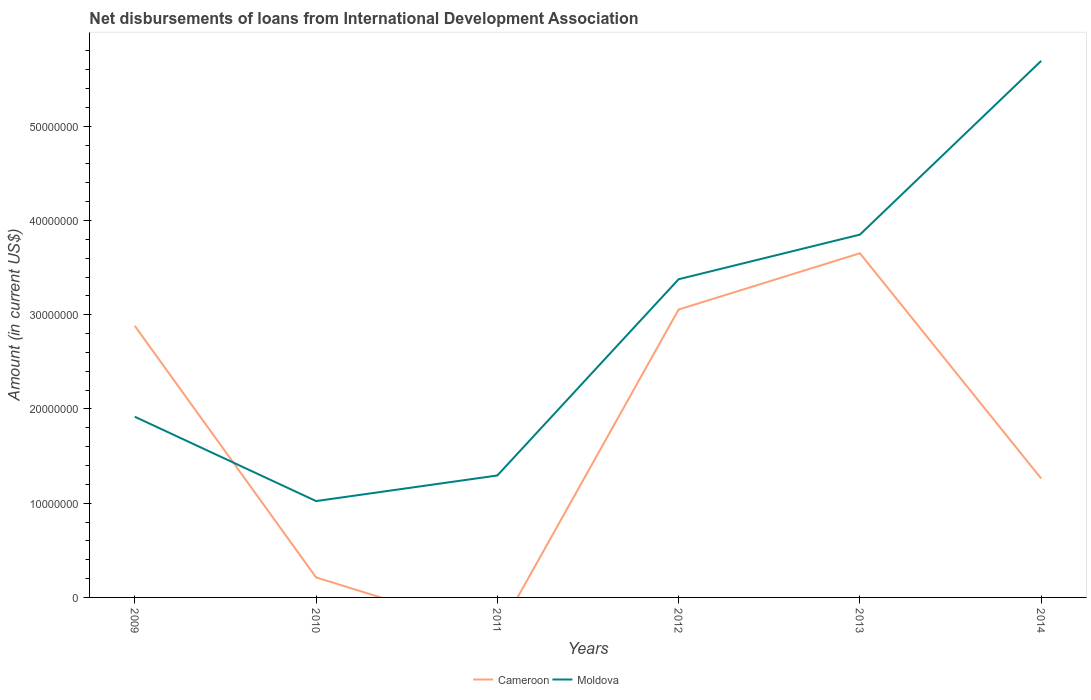How many different coloured lines are there?
Ensure brevity in your answer.  2. Does the line corresponding to Moldova intersect with the line corresponding to Cameroon?
Offer a very short reply. Yes. Is the number of lines equal to the number of legend labels?
Ensure brevity in your answer.  No. What is the total amount of loans disbursed in Moldova in the graph?
Provide a succinct answer. -4.40e+07. What is the difference between the highest and the second highest amount of loans disbursed in Moldova?
Offer a very short reply. 4.67e+07. What is the difference between the highest and the lowest amount of loans disbursed in Moldova?
Ensure brevity in your answer.  3. Is the amount of loans disbursed in Moldova strictly greater than the amount of loans disbursed in Cameroon over the years?
Offer a terse response. No. How many years are there in the graph?
Keep it short and to the point. 6. What is the difference between two consecutive major ticks on the Y-axis?
Make the answer very short. 1.00e+07. Are the values on the major ticks of Y-axis written in scientific E-notation?
Your answer should be very brief. No. Where does the legend appear in the graph?
Give a very brief answer. Bottom center. What is the title of the graph?
Your answer should be compact. Net disbursements of loans from International Development Association. Does "El Salvador" appear as one of the legend labels in the graph?
Offer a very short reply. No. What is the Amount (in current US$) in Cameroon in 2009?
Your response must be concise. 2.88e+07. What is the Amount (in current US$) of Moldova in 2009?
Make the answer very short. 1.92e+07. What is the Amount (in current US$) of Cameroon in 2010?
Keep it short and to the point. 2.12e+06. What is the Amount (in current US$) in Moldova in 2010?
Your answer should be very brief. 1.02e+07. What is the Amount (in current US$) of Moldova in 2011?
Offer a very short reply. 1.29e+07. What is the Amount (in current US$) of Cameroon in 2012?
Make the answer very short. 3.06e+07. What is the Amount (in current US$) in Moldova in 2012?
Offer a terse response. 3.38e+07. What is the Amount (in current US$) in Cameroon in 2013?
Keep it short and to the point. 3.65e+07. What is the Amount (in current US$) in Moldova in 2013?
Provide a short and direct response. 3.85e+07. What is the Amount (in current US$) in Cameroon in 2014?
Offer a terse response. 1.26e+07. What is the Amount (in current US$) in Moldova in 2014?
Your answer should be very brief. 5.69e+07. Across all years, what is the maximum Amount (in current US$) of Cameroon?
Provide a short and direct response. 3.65e+07. Across all years, what is the maximum Amount (in current US$) in Moldova?
Ensure brevity in your answer.  5.69e+07. Across all years, what is the minimum Amount (in current US$) in Moldova?
Your answer should be very brief. 1.02e+07. What is the total Amount (in current US$) of Cameroon in the graph?
Ensure brevity in your answer.  1.11e+08. What is the total Amount (in current US$) in Moldova in the graph?
Keep it short and to the point. 1.72e+08. What is the difference between the Amount (in current US$) of Cameroon in 2009 and that in 2010?
Give a very brief answer. 2.67e+07. What is the difference between the Amount (in current US$) of Moldova in 2009 and that in 2010?
Ensure brevity in your answer.  8.95e+06. What is the difference between the Amount (in current US$) of Moldova in 2009 and that in 2011?
Your answer should be compact. 6.23e+06. What is the difference between the Amount (in current US$) in Cameroon in 2009 and that in 2012?
Make the answer very short. -1.74e+06. What is the difference between the Amount (in current US$) in Moldova in 2009 and that in 2012?
Your response must be concise. -1.46e+07. What is the difference between the Amount (in current US$) in Cameroon in 2009 and that in 2013?
Keep it short and to the point. -7.70e+06. What is the difference between the Amount (in current US$) in Moldova in 2009 and that in 2013?
Make the answer very short. -1.93e+07. What is the difference between the Amount (in current US$) of Cameroon in 2009 and that in 2014?
Provide a short and direct response. 1.62e+07. What is the difference between the Amount (in current US$) of Moldova in 2009 and that in 2014?
Provide a short and direct response. -3.78e+07. What is the difference between the Amount (in current US$) of Moldova in 2010 and that in 2011?
Give a very brief answer. -2.72e+06. What is the difference between the Amount (in current US$) in Cameroon in 2010 and that in 2012?
Offer a very short reply. -2.84e+07. What is the difference between the Amount (in current US$) in Moldova in 2010 and that in 2012?
Your answer should be compact. -2.35e+07. What is the difference between the Amount (in current US$) in Cameroon in 2010 and that in 2013?
Offer a very short reply. -3.44e+07. What is the difference between the Amount (in current US$) of Moldova in 2010 and that in 2013?
Your response must be concise. -2.83e+07. What is the difference between the Amount (in current US$) of Cameroon in 2010 and that in 2014?
Offer a terse response. -1.05e+07. What is the difference between the Amount (in current US$) in Moldova in 2010 and that in 2014?
Your response must be concise. -4.67e+07. What is the difference between the Amount (in current US$) in Moldova in 2011 and that in 2012?
Ensure brevity in your answer.  -2.08e+07. What is the difference between the Amount (in current US$) of Moldova in 2011 and that in 2013?
Your response must be concise. -2.56e+07. What is the difference between the Amount (in current US$) of Moldova in 2011 and that in 2014?
Your answer should be very brief. -4.40e+07. What is the difference between the Amount (in current US$) in Cameroon in 2012 and that in 2013?
Give a very brief answer. -5.97e+06. What is the difference between the Amount (in current US$) in Moldova in 2012 and that in 2013?
Offer a terse response. -4.73e+06. What is the difference between the Amount (in current US$) of Cameroon in 2012 and that in 2014?
Ensure brevity in your answer.  1.79e+07. What is the difference between the Amount (in current US$) of Moldova in 2012 and that in 2014?
Make the answer very short. -2.32e+07. What is the difference between the Amount (in current US$) in Cameroon in 2013 and that in 2014?
Offer a very short reply. 2.39e+07. What is the difference between the Amount (in current US$) of Moldova in 2013 and that in 2014?
Your answer should be compact. -1.84e+07. What is the difference between the Amount (in current US$) in Cameroon in 2009 and the Amount (in current US$) in Moldova in 2010?
Your response must be concise. 1.86e+07. What is the difference between the Amount (in current US$) in Cameroon in 2009 and the Amount (in current US$) in Moldova in 2011?
Your answer should be compact. 1.59e+07. What is the difference between the Amount (in current US$) of Cameroon in 2009 and the Amount (in current US$) of Moldova in 2012?
Your answer should be compact. -4.95e+06. What is the difference between the Amount (in current US$) in Cameroon in 2009 and the Amount (in current US$) in Moldova in 2013?
Make the answer very short. -9.68e+06. What is the difference between the Amount (in current US$) of Cameroon in 2009 and the Amount (in current US$) of Moldova in 2014?
Your answer should be compact. -2.81e+07. What is the difference between the Amount (in current US$) of Cameroon in 2010 and the Amount (in current US$) of Moldova in 2011?
Offer a terse response. -1.08e+07. What is the difference between the Amount (in current US$) of Cameroon in 2010 and the Amount (in current US$) of Moldova in 2012?
Offer a terse response. -3.16e+07. What is the difference between the Amount (in current US$) in Cameroon in 2010 and the Amount (in current US$) in Moldova in 2013?
Offer a very short reply. -3.64e+07. What is the difference between the Amount (in current US$) in Cameroon in 2010 and the Amount (in current US$) in Moldova in 2014?
Keep it short and to the point. -5.48e+07. What is the difference between the Amount (in current US$) of Cameroon in 2012 and the Amount (in current US$) of Moldova in 2013?
Provide a succinct answer. -7.95e+06. What is the difference between the Amount (in current US$) in Cameroon in 2012 and the Amount (in current US$) in Moldova in 2014?
Provide a succinct answer. -2.64e+07. What is the difference between the Amount (in current US$) in Cameroon in 2013 and the Amount (in current US$) in Moldova in 2014?
Make the answer very short. -2.04e+07. What is the average Amount (in current US$) of Cameroon per year?
Ensure brevity in your answer.  1.84e+07. What is the average Amount (in current US$) of Moldova per year?
Your response must be concise. 2.86e+07. In the year 2009, what is the difference between the Amount (in current US$) of Cameroon and Amount (in current US$) of Moldova?
Keep it short and to the point. 9.64e+06. In the year 2010, what is the difference between the Amount (in current US$) in Cameroon and Amount (in current US$) in Moldova?
Make the answer very short. -8.10e+06. In the year 2012, what is the difference between the Amount (in current US$) in Cameroon and Amount (in current US$) in Moldova?
Your response must be concise. -3.21e+06. In the year 2013, what is the difference between the Amount (in current US$) in Cameroon and Amount (in current US$) in Moldova?
Offer a terse response. -1.98e+06. In the year 2014, what is the difference between the Amount (in current US$) in Cameroon and Amount (in current US$) in Moldova?
Your answer should be compact. -4.43e+07. What is the ratio of the Amount (in current US$) of Cameroon in 2009 to that in 2010?
Your answer should be very brief. 13.56. What is the ratio of the Amount (in current US$) of Moldova in 2009 to that in 2010?
Your answer should be compact. 1.88. What is the ratio of the Amount (in current US$) of Moldova in 2009 to that in 2011?
Your answer should be compact. 1.48. What is the ratio of the Amount (in current US$) of Cameroon in 2009 to that in 2012?
Your response must be concise. 0.94. What is the ratio of the Amount (in current US$) of Moldova in 2009 to that in 2012?
Ensure brevity in your answer.  0.57. What is the ratio of the Amount (in current US$) in Cameroon in 2009 to that in 2013?
Keep it short and to the point. 0.79. What is the ratio of the Amount (in current US$) of Moldova in 2009 to that in 2013?
Offer a terse response. 0.5. What is the ratio of the Amount (in current US$) of Cameroon in 2009 to that in 2014?
Offer a terse response. 2.28. What is the ratio of the Amount (in current US$) in Moldova in 2009 to that in 2014?
Keep it short and to the point. 0.34. What is the ratio of the Amount (in current US$) of Moldova in 2010 to that in 2011?
Ensure brevity in your answer.  0.79. What is the ratio of the Amount (in current US$) of Cameroon in 2010 to that in 2012?
Provide a short and direct response. 0.07. What is the ratio of the Amount (in current US$) in Moldova in 2010 to that in 2012?
Offer a terse response. 0.3. What is the ratio of the Amount (in current US$) in Cameroon in 2010 to that in 2013?
Offer a terse response. 0.06. What is the ratio of the Amount (in current US$) in Moldova in 2010 to that in 2013?
Make the answer very short. 0.27. What is the ratio of the Amount (in current US$) in Cameroon in 2010 to that in 2014?
Give a very brief answer. 0.17. What is the ratio of the Amount (in current US$) of Moldova in 2010 to that in 2014?
Your answer should be very brief. 0.18. What is the ratio of the Amount (in current US$) in Moldova in 2011 to that in 2012?
Offer a very short reply. 0.38. What is the ratio of the Amount (in current US$) of Moldova in 2011 to that in 2013?
Provide a succinct answer. 0.34. What is the ratio of the Amount (in current US$) of Moldova in 2011 to that in 2014?
Offer a very short reply. 0.23. What is the ratio of the Amount (in current US$) of Cameroon in 2012 to that in 2013?
Provide a succinct answer. 0.84. What is the ratio of the Amount (in current US$) in Moldova in 2012 to that in 2013?
Your response must be concise. 0.88. What is the ratio of the Amount (in current US$) of Cameroon in 2012 to that in 2014?
Provide a short and direct response. 2.42. What is the ratio of the Amount (in current US$) in Moldova in 2012 to that in 2014?
Your response must be concise. 0.59. What is the ratio of the Amount (in current US$) in Cameroon in 2013 to that in 2014?
Your answer should be very brief. 2.89. What is the ratio of the Amount (in current US$) in Moldova in 2013 to that in 2014?
Provide a short and direct response. 0.68. What is the difference between the highest and the second highest Amount (in current US$) in Cameroon?
Keep it short and to the point. 5.97e+06. What is the difference between the highest and the second highest Amount (in current US$) of Moldova?
Provide a succinct answer. 1.84e+07. What is the difference between the highest and the lowest Amount (in current US$) of Cameroon?
Ensure brevity in your answer.  3.65e+07. What is the difference between the highest and the lowest Amount (in current US$) of Moldova?
Ensure brevity in your answer.  4.67e+07. 